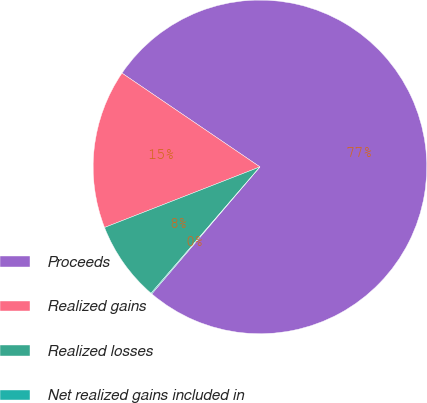Convert chart. <chart><loc_0><loc_0><loc_500><loc_500><pie_chart><fcel>Proceeds<fcel>Realized gains<fcel>Realized losses<fcel>Net realized gains included in<nl><fcel>76.73%<fcel>15.42%<fcel>7.76%<fcel>0.09%<nl></chart> 